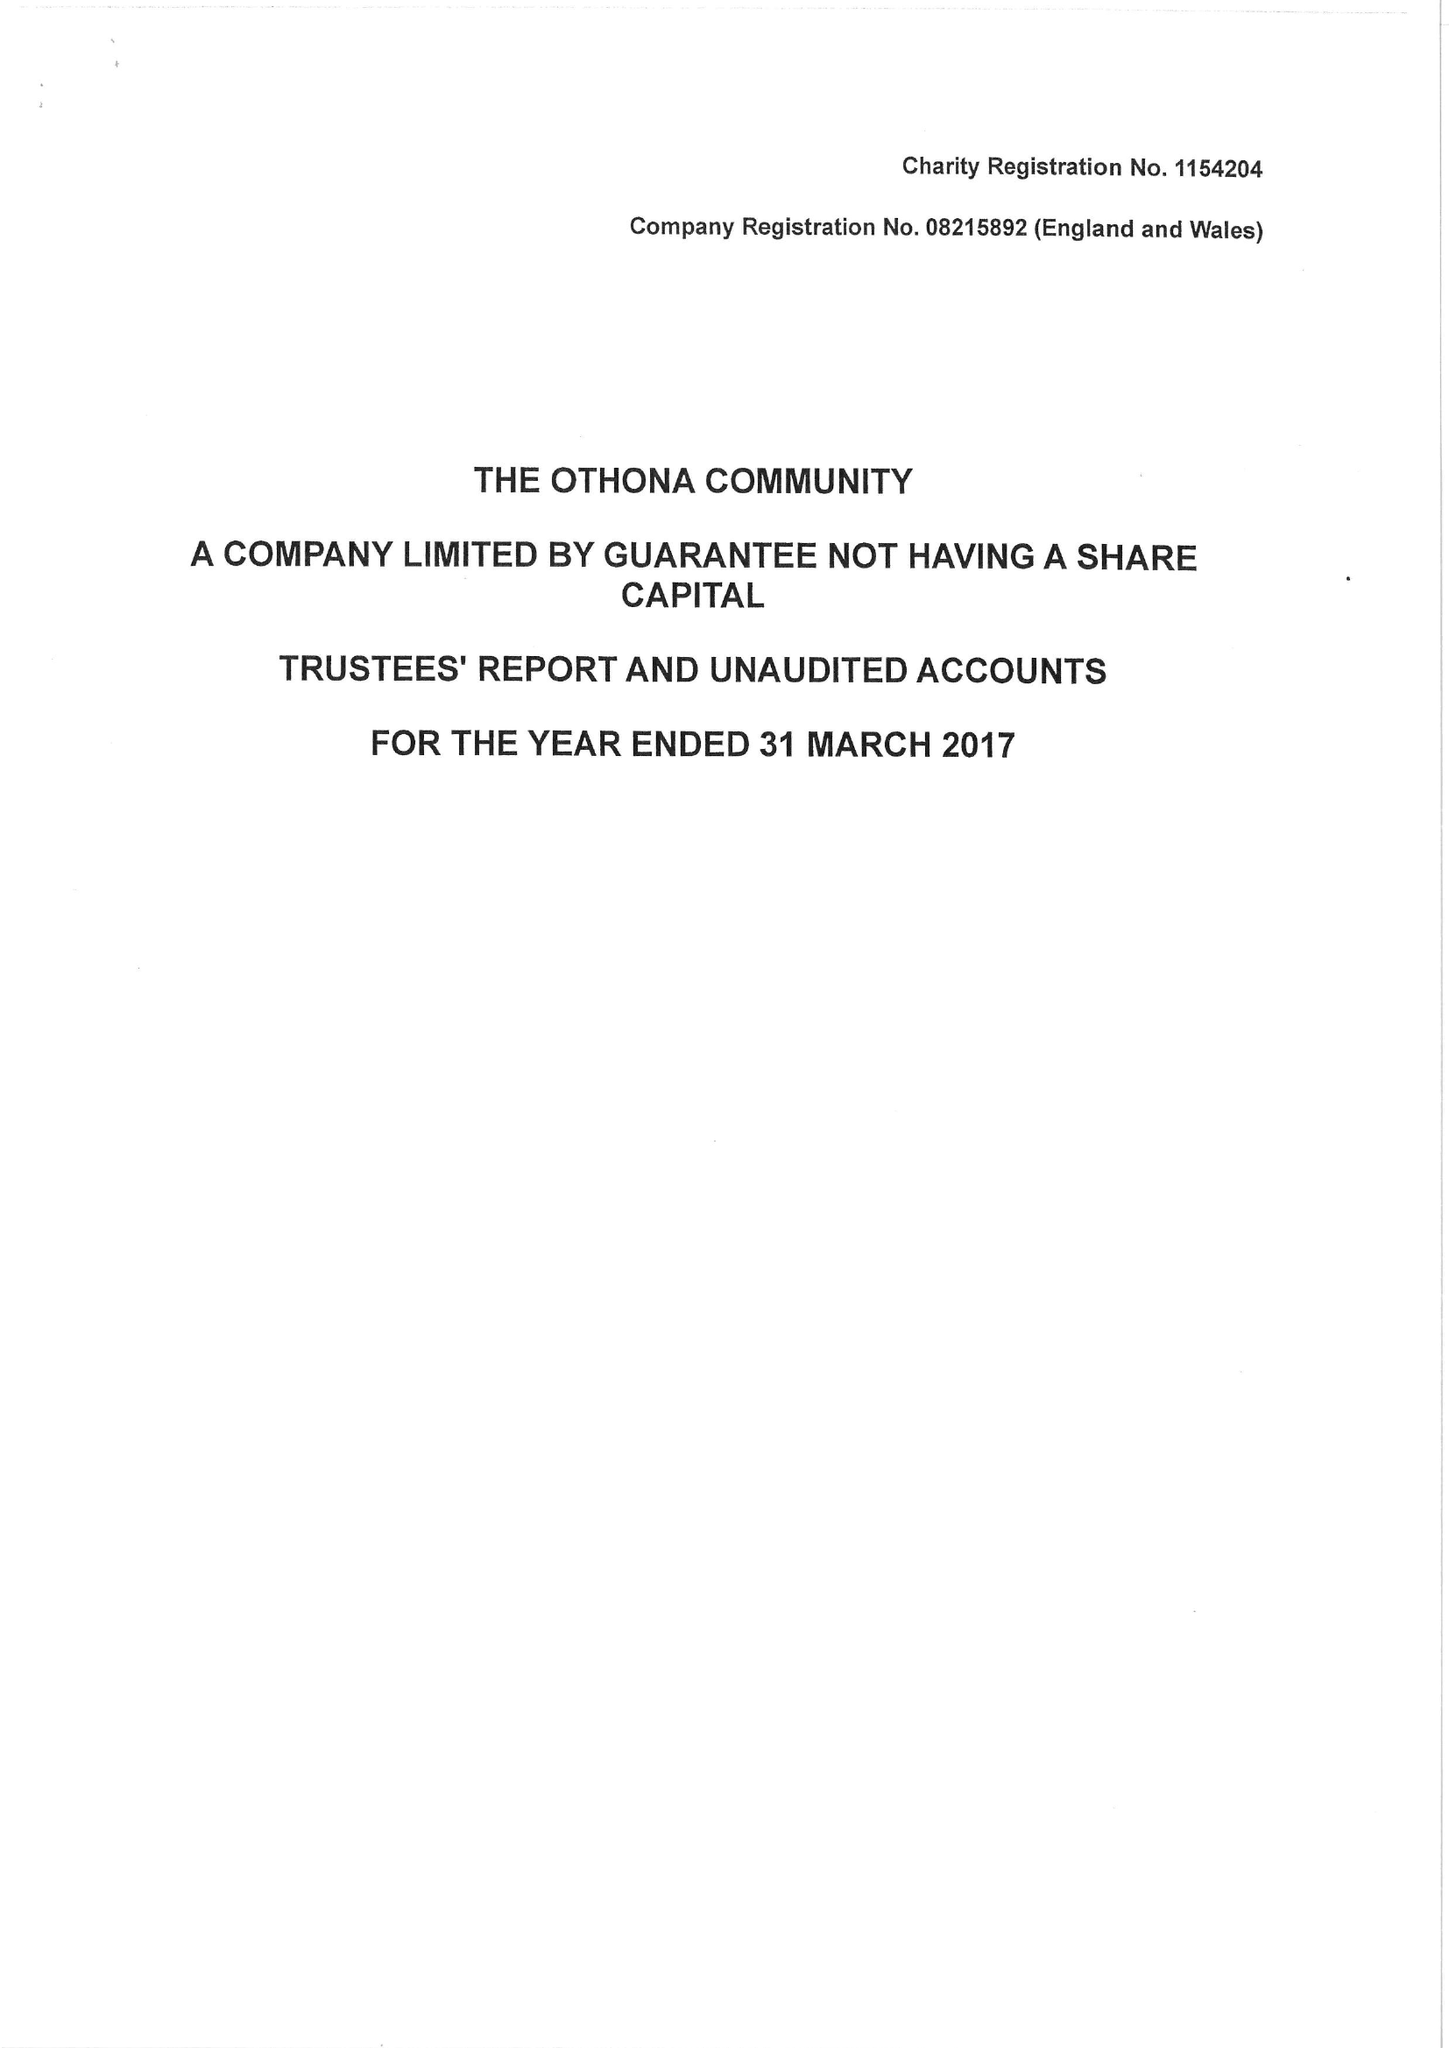What is the value for the address__postcode?
Answer the question using a single word or phrase. CM0 7HN 